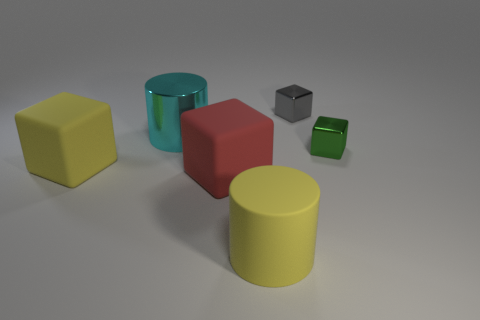Which object stands out the most, and why? The large red cube stands out due to its bold color and central placement within the scene, drawing the viewer's focus amid more neutrally colored objects. Is there any sense of movement or stillness in the image? The image conveys a sense of stillness; the objects are stationary with no indication of movement, arranged as if part of a still life study. 